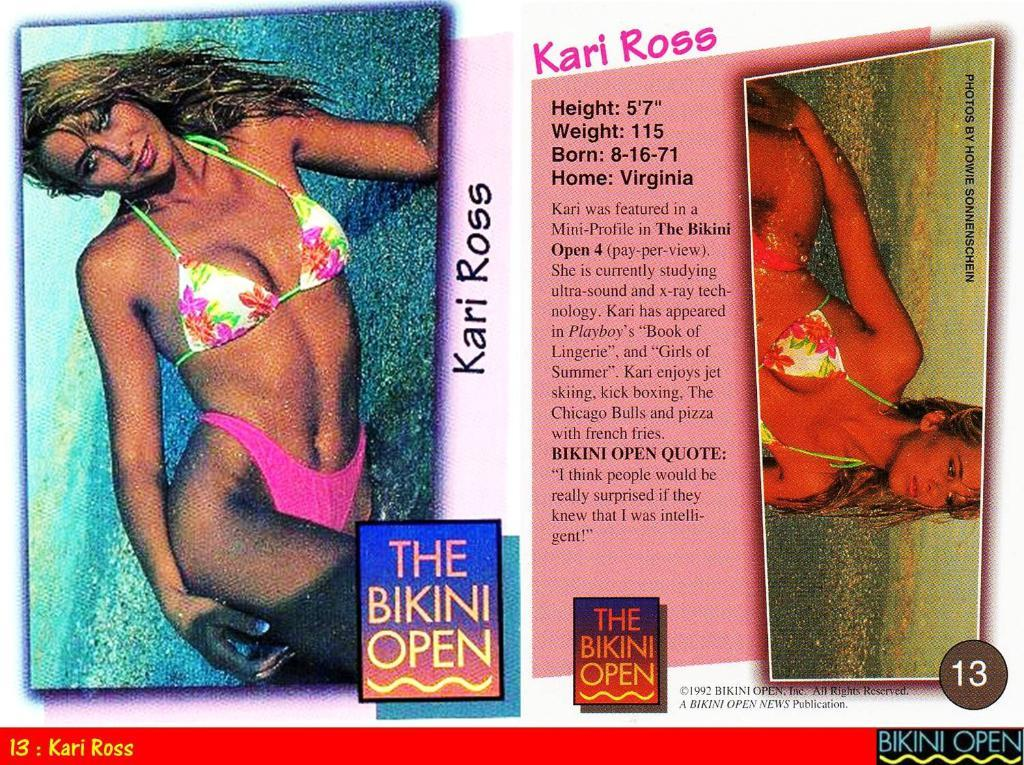What type of items can be seen in the image? There are articles in the image. Can you describe the person in the image? There is a woman in the image. What is the woman wearing? The woman is wearing a bikini. On which side of the image is the woman located? The woman is on the left side of the image. What type of facial expression does the woman have in the image? There is no information about the woman's facial expression in the provided facts, so we cannot answer this question. How many oranges are visible in the image? There is no mention of oranges in the provided facts, so we cannot answer this question. 